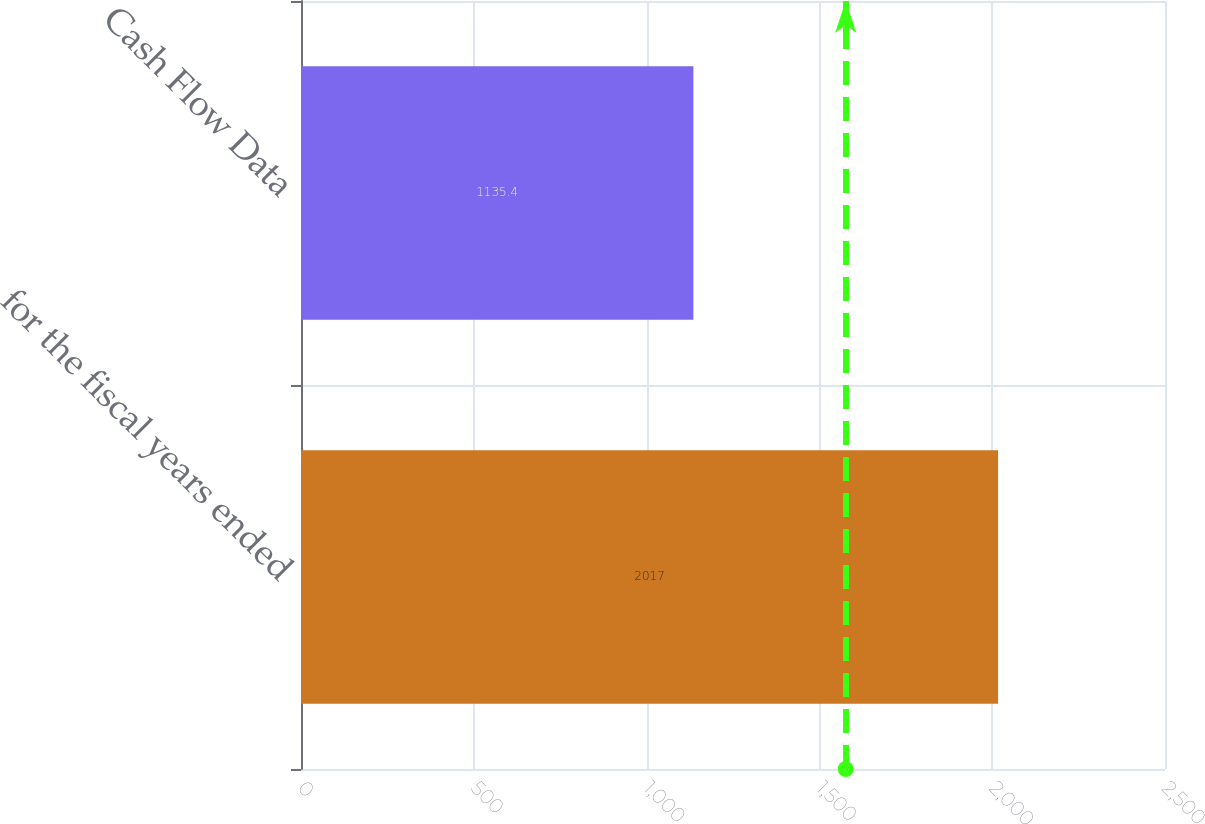Convert chart to OTSL. <chart><loc_0><loc_0><loc_500><loc_500><bar_chart><fcel>for the fiscal years ended<fcel>Cash Flow Data<nl><fcel>2017<fcel>1135.4<nl></chart> 